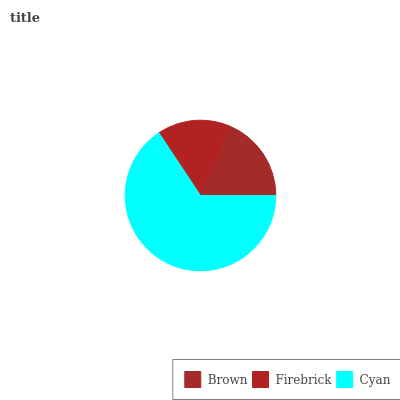Is Firebrick the minimum?
Answer yes or no. Yes. Is Cyan the maximum?
Answer yes or no. Yes. Is Cyan the minimum?
Answer yes or no. No. Is Firebrick the maximum?
Answer yes or no. No. Is Cyan greater than Firebrick?
Answer yes or no. Yes. Is Firebrick less than Cyan?
Answer yes or no. Yes. Is Firebrick greater than Cyan?
Answer yes or no. No. Is Cyan less than Firebrick?
Answer yes or no. No. Is Brown the high median?
Answer yes or no. Yes. Is Brown the low median?
Answer yes or no. Yes. Is Cyan the high median?
Answer yes or no. No. Is Cyan the low median?
Answer yes or no. No. 